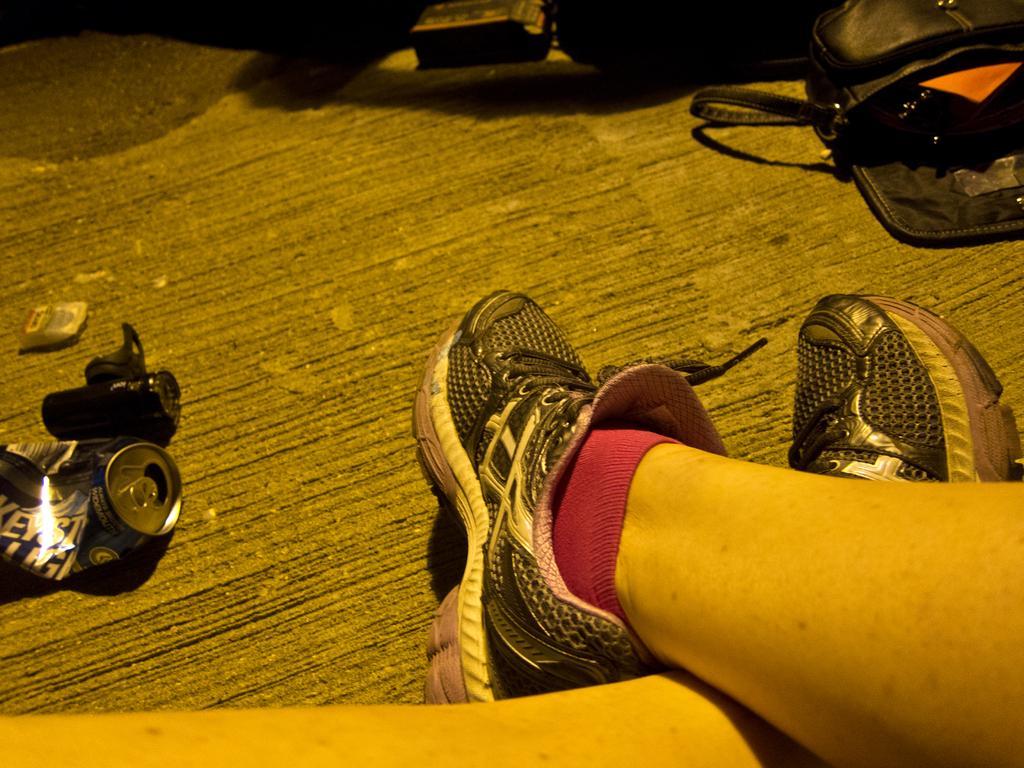How would you summarize this image in a sentence or two? In this image we can see person's legs, beverage tin and the bag on the floor. 